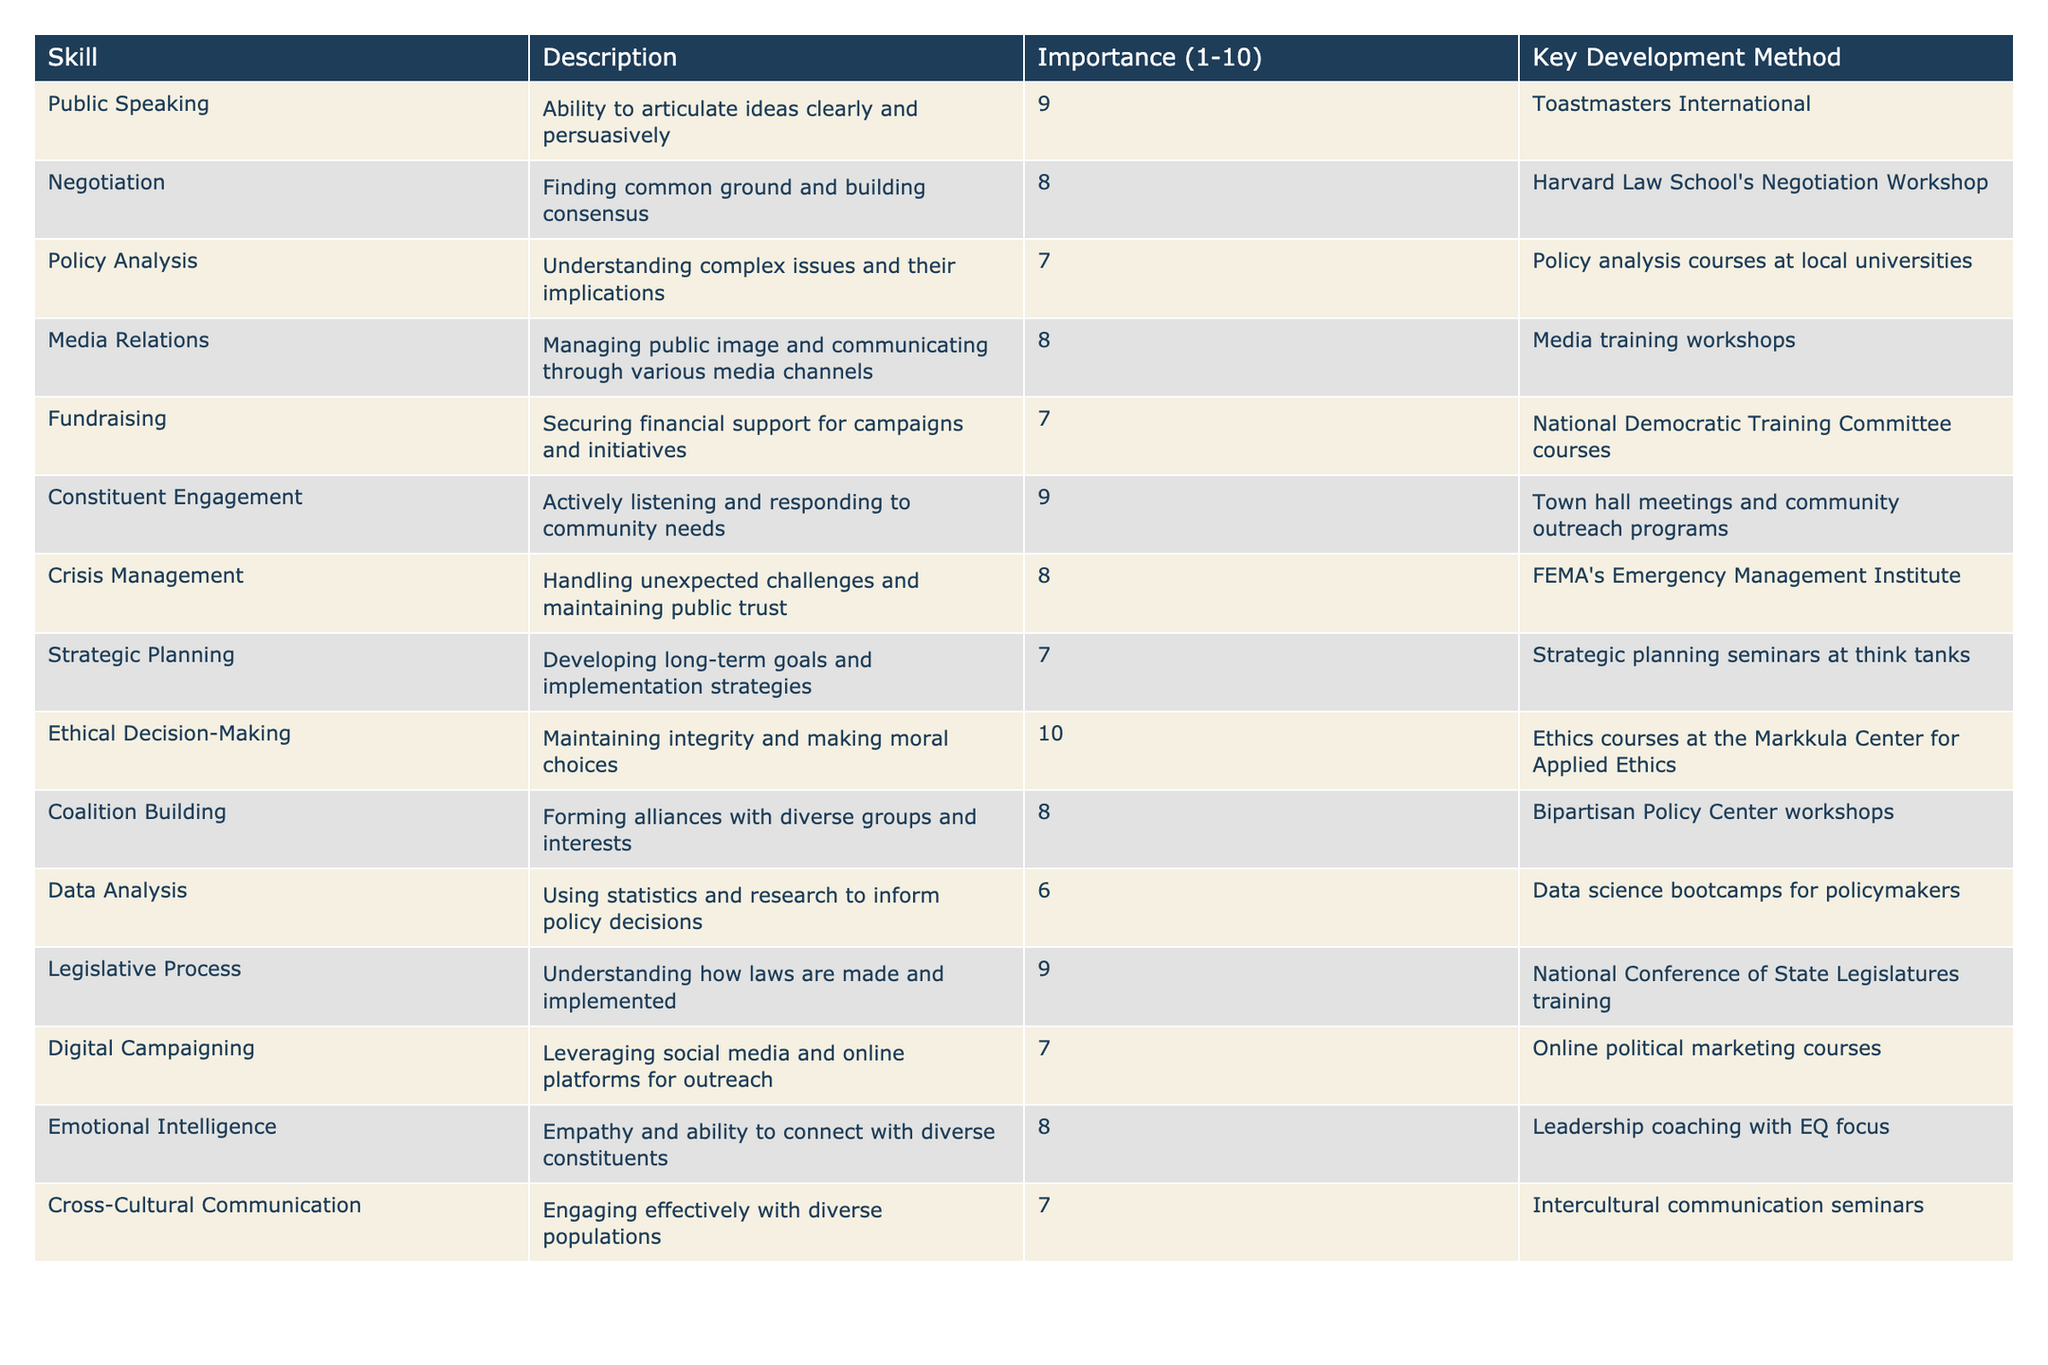What is the skill with the highest importance score? The table shows the importance scores for each skill, which range from 1 to 10. Looking through the list, "Ethical Decision-Making" has the highest score of 10.
Answer: Ethical Decision-Making Which skill has a lower importance score: Data Analysis or Fundraising? The importance score for Data Analysis is 6, while for Fundraising it is 7. Since 6 is less than 7, Data Analysis has the lower score.
Answer: Data Analysis How many skills have an importance score of 8 or higher? The skills with scores of 8 or higher are Public Speaking, Negotiation, Media Relations, Constituent Engagement, Crisis Management, Coalition Building, and Emotional Intelligence. Counting these gives 7 skills in total.
Answer: 7 Which key development method is associated with Crisis Management? The key development method listed for Crisis Management in the table is FEMA's Emergency Management Institute.
Answer: FEMA's Emergency Management Institute What is the average importance score of skills related to communication? The skills related to communication are Public Speaking (9), Media Relations (8), Constituent Engagement (9), Emotional Intelligence (8), and Cross-Cultural Communication (7). Adding these scores gives 41, and dividing by 5 (the number of skills) results in an average of 8.2.
Answer: 8.2 Is the key development method for Digital Campaigning listed in the table? Yes, the key development method for Digital Campaigning is "Online political marketing courses," which can be found in the table.
Answer: Yes Can you identify a skill with an importance score that is greater than 6 but less than 8? The skills that fit this criterion are Policy Analysis (7) and Digital Campaigning (7). Both of these have scores greater than 6 and less than 8.
Answer: Policy Analysis, Digital Campaigning What is the importance score difference between Ethical Decision-Making and Data Analysis? Ethical Decision-Making has an importance score of 10, while Data Analysis has a score of 6. The difference is calculated as 10 - 6 = 4.
Answer: 4 Which two skills both have an importance score of 8? The two skills with an importance score of 8 are Negotiation and Media Relations.
Answer: Negotiation, Media Relations What is the sum of the importance scores for all skills? To find the sum, add all the importance scores: 9 + 8 + 7 + 8 + 7 + 9 + 8 + 7 + 10 + 8 + 6 + 9 + 7 + 8 = 100. The total importance score for all skills is 100.
Answer: 100 